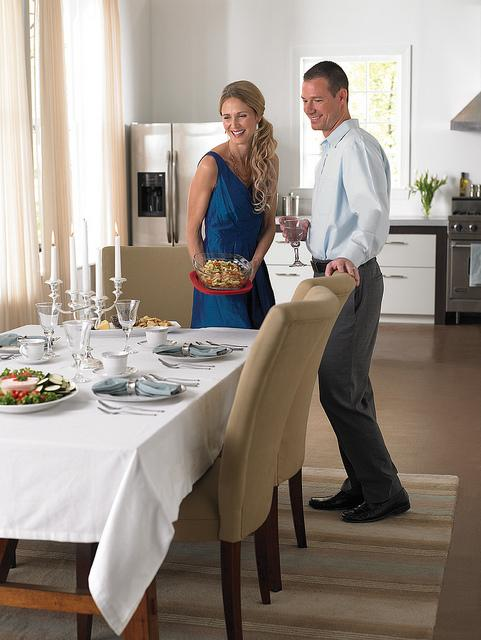What is the name of dining candles? Please explain your reasoning. votives. Long dining candles are called votive candles. 